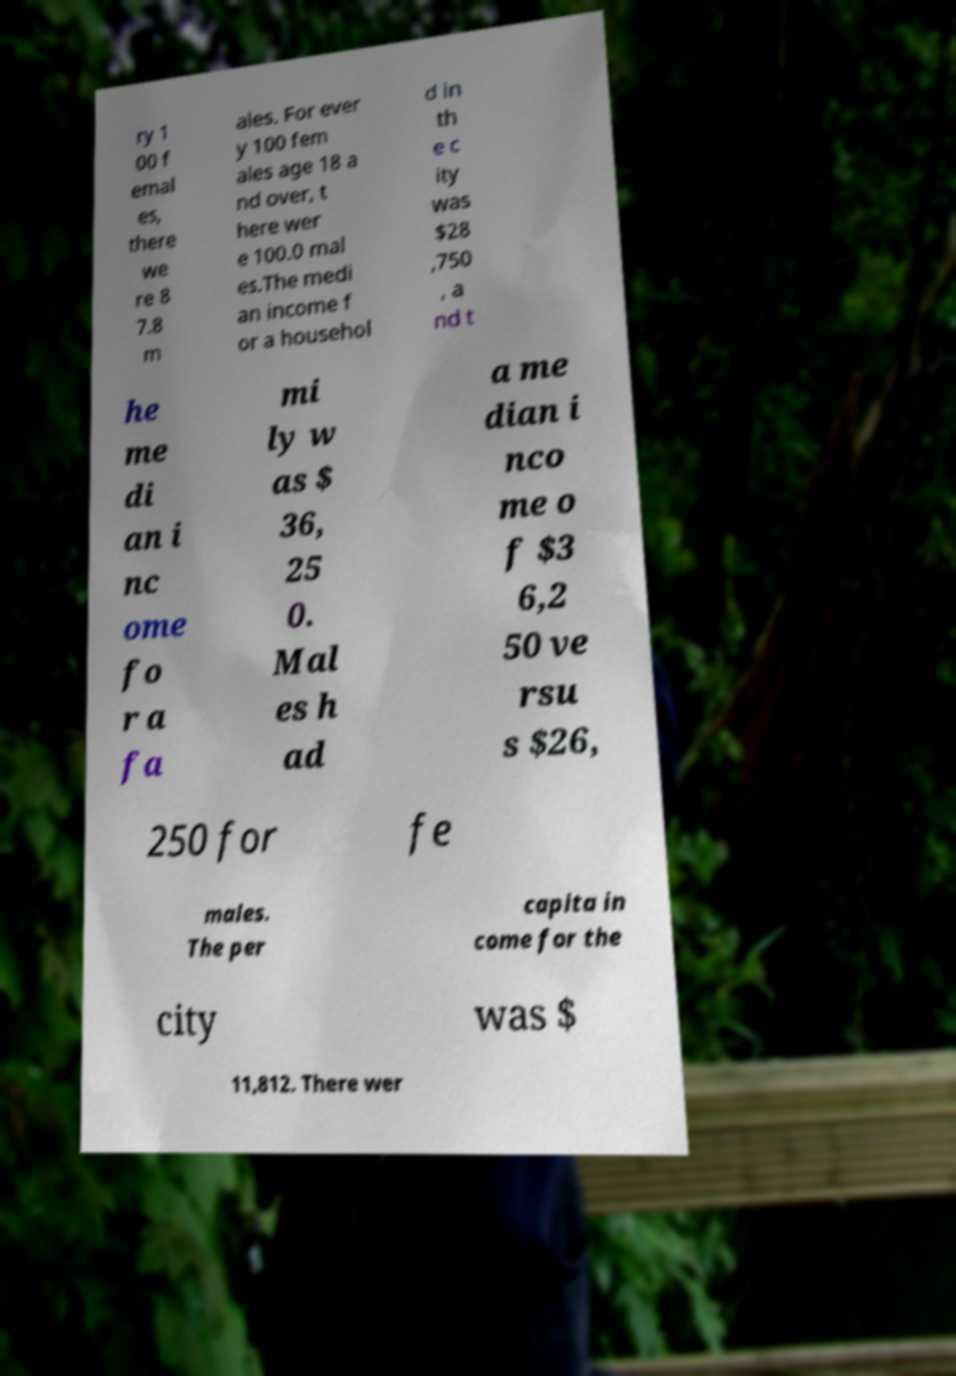Please identify and transcribe the text found in this image. ry 1 00 f emal es, there we re 8 7.8 m ales. For ever y 100 fem ales age 18 a nd over, t here wer e 100.0 mal es.The medi an income f or a househol d in th e c ity was $28 ,750 , a nd t he me di an i nc ome fo r a fa mi ly w as $ 36, 25 0. Mal es h ad a me dian i nco me o f $3 6,2 50 ve rsu s $26, 250 for fe males. The per capita in come for the city was $ 11,812. There wer 